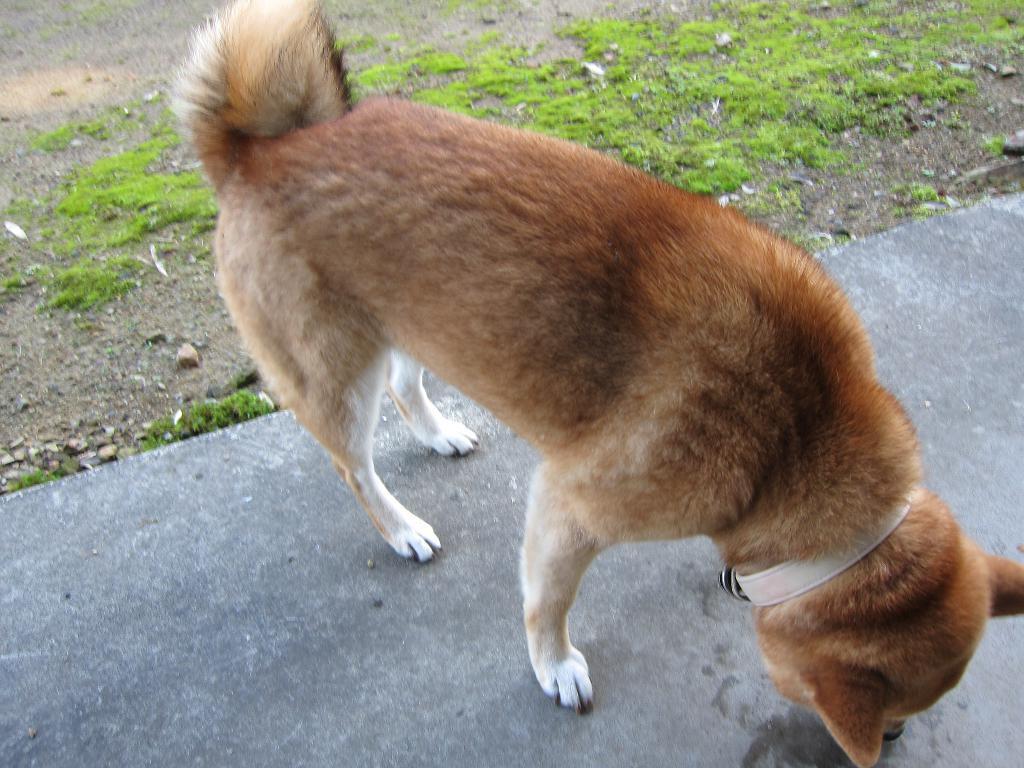Could you give a brief overview of what you see in this image? In this picture we can see a dog with a belt on it and this dog is on the ground and we can see grass in the background. 